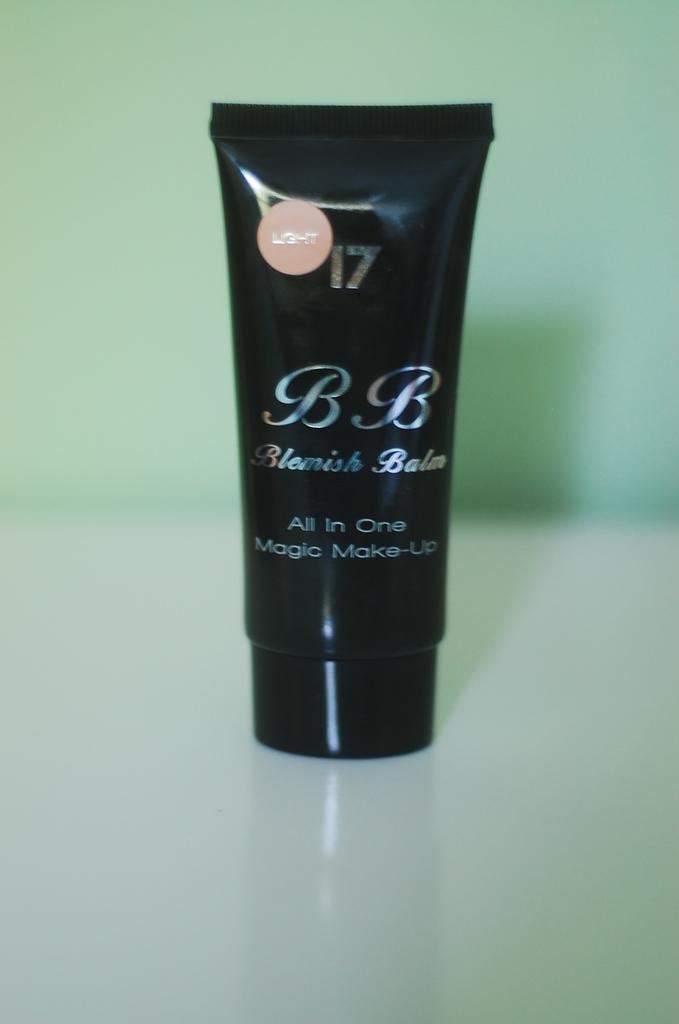<image>
Offer a succinct explanation of the picture presented. A black makeup bottle with the words Blemish Balm under the letters B.B. 